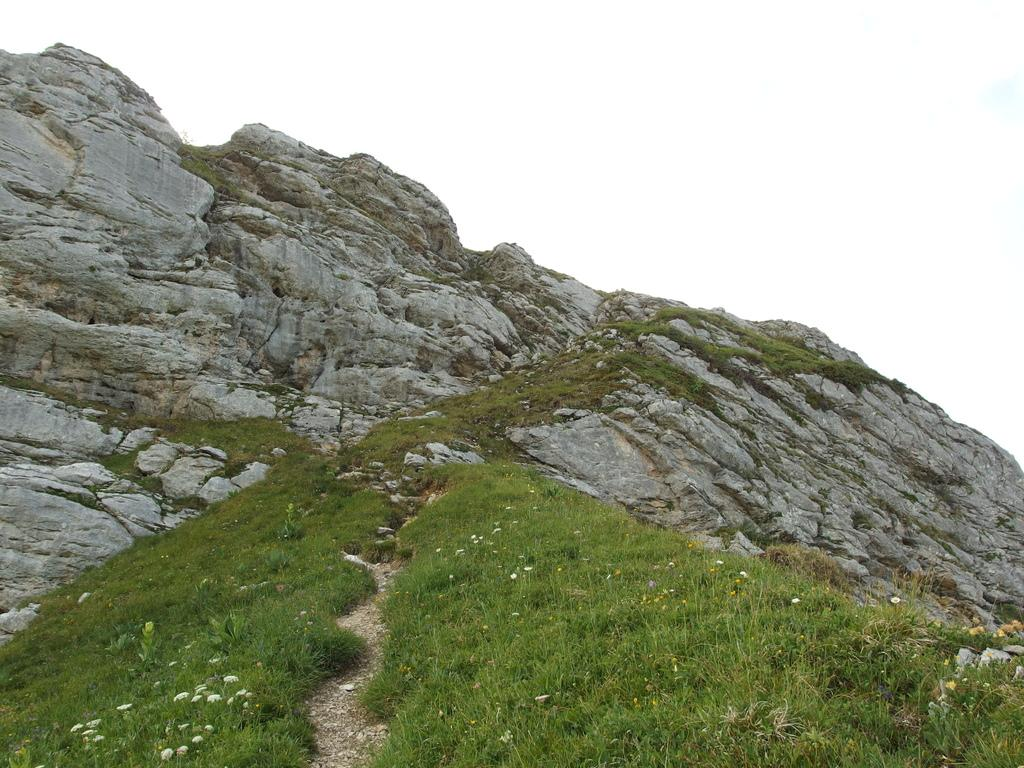What is the main feature of the landscape in the image? There is a hill in the image. What type of vegetation is present at the bottom of the hill? Grass is present at the bottom of the hill. What can be found within the grass at the bottom of the hill? There are stones in the grass. What purpose does the paper serve in the image? There is no paper present in the image. Can you describe the zipper on the hill in the image? There is no zipper present in the image. 